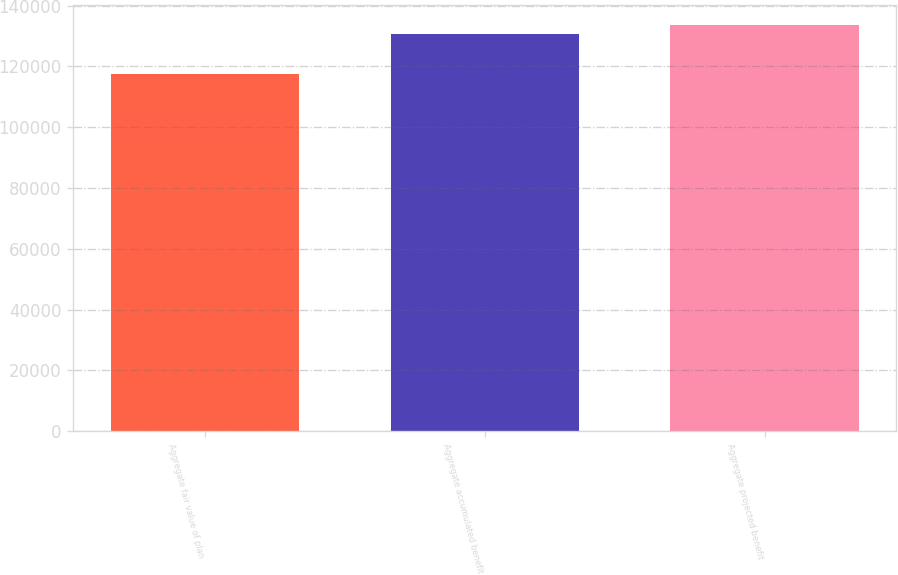Convert chart to OTSL. <chart><loc_0><loc_0><loc_500><loc_500><bar_chart><fcel>Aggregate fair value of plan<fcel>Aggregate accumulated benefit<fcel>Aggregate projected benefit<nl><fcel>117504<fcel>130669<fcel>133672<nl></chart> 